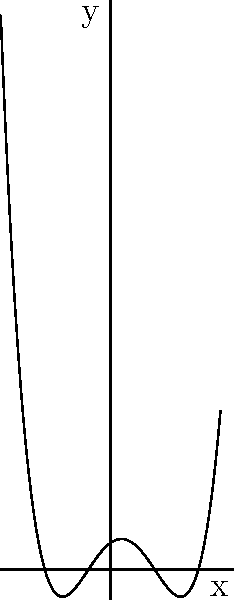As a photojournalist, you've captured an image of a polynomial graph to support a researcher's findings on climate change patterns. Based on the visual representation, what is the degree of this polynomial? To determine the degree of a polynomial from its graph, we need to follow these steps:

1. Count the number of x-intercepts (roots) visible in the graph:
   - There are 4 distinct x-intercepts visible.

2. Check for any turning points (local maxima or minima):
   - The graph has 3 turning points.

3. Examine the end behavior of the graph:
   - As x approaches positive infinity, y approaches positive infinity.
   - As x approaches negative infinity, y approaches negative infinity.

4. Use the information gathered to determine the degree:
   - The maximum number of x-intercepts for a polynomial of degree n is n.
   - The maximum number of turning points for a polynomial of degree n is (n-1).
   - The end behavior we observed is consistent with an odd-degree polynomial.

5. Conclusion:
   - The polynomial has 4 x-intercepts, which requires at least a 4th-degree polynomial.
   - It has 3 turning points, which is consistent with a 4th-degree polynomial (4-1 = 3).
   - The end behavior also matches a 4th-degree polynomial with a positive leading coefficient.

Therefore, the degree of this polynomial is 4.
Answer: 4 